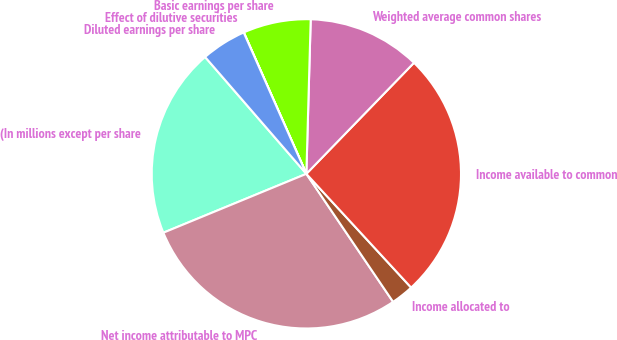Convert chart. <chart><loc_0><loc_0><loc_500><loc_500><pie_chart><fcel>(In millions except per share<fcel>Net income attributable to MPC<fcel>Income allocated to<fcel>Income available to common<fcel>Weighted average common shares<fcel>Basic earnings per share<fcel>Effect of dilutive securities<fcel>Diluted earnings per share<nl><fcel>19.85%<fcel>28.26%<fcel>2.37%<fcel>25.9%<fcel>11.8%<fcel>7.08%<fcel>0.01%<fcel>4.72%<nl></chart> 